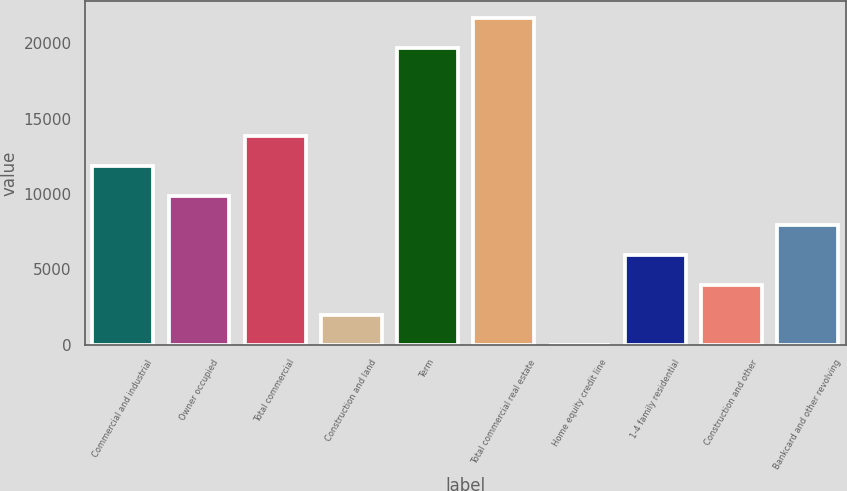Convert chart. <chart><loc_0><loc_0><loc_500><loc_500><bar_chart><fcel>Commercial and industrial<fcel>Owner occupied<fcel>Total commercial<fcel>Construction and land<fcel>Term<fcel>Total commercial real estate<fcel>Home equity credit line<fcel>1-4 family residential<fcel>Construction and other<fcel>Bankcard and other revolving<nl><fcel>11875.6<fcel>9896.5<fcel>13854.7<fcel>1980.1<fcel>19700<fcel>21679.1<fcel>1<fcel>5938.3<fcel>3959.2<fcel>7917.4<nl></chart> 